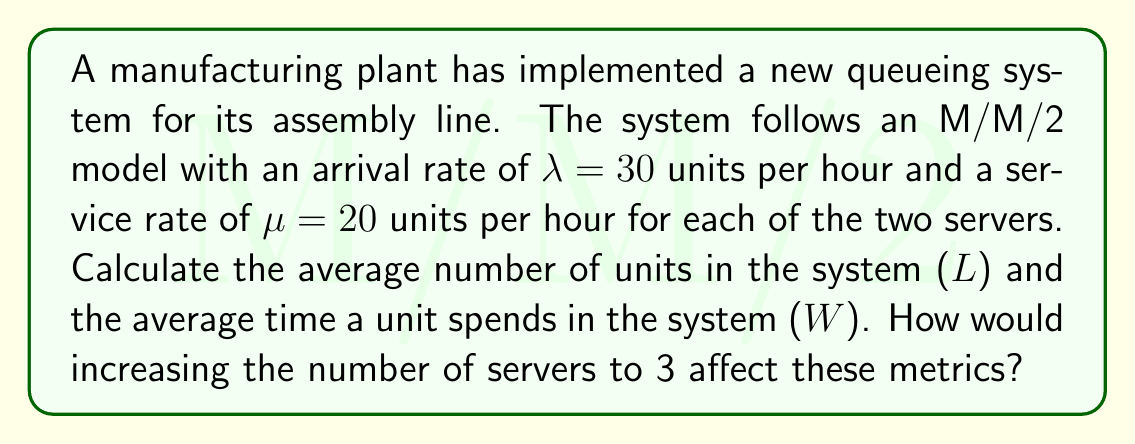Can you answer this question? To solve this problem, we'll use the formulas for an M/M/c queueing system, where c is the number of servers.

Step 1: Calculate the utilization factor ρ
$$\rho = \frac{\lambda}{c\mu} = \frac{30}{2 \cdot 20} = 0.75$$

Step 2: Calculate P0 (probability of an empty system)
$$P_0 = \left[\sum_{n=0}^{c-1}\frac{(c\rho)^n}{n!} + \frac{(c\rho)^c}{c!(1-\rho)}\right]^{-1}$$
$$P_0 = \left[1 + \frac{(2 \cdot 0.75)^1}{1!} + \frac{(2 \cdot 0.75)^2}{2!(1-0.75)}\right]^{-1} = 0.1739$$

Step 3: Calculate Lq (average number of units in the queue)
$$L_q = \frac{P_0(c\rho)^c\rho}{c!(1-\rho)^2} = \frac{0.1739 \cdot (2 \cdot 0.75)^2 \cdot 0.75}{2!(1-0.75)^2} = 2.25$$

Step 4: Calculate L (average number of units in the system)
$$L = L_q + c\rho = 2.25 + 2 \cdot 0.75 = 3.75$$

Step 5: Calculate W (average time a unit spends in the system)
$$W = \frac{L}{\lambda} = \frac{3.75}{30} = 0.125 \text{ hours} = 7.5 \text{ minutes}$$

For the second part of the question, if we increase the number of servers to 3:

Step 1: Recalculate ρ
$$\rho = \frac{\lambda}{c\mu} = \frac{30}{3 \cdot 20} = 0.5$$

Step 2: Recalculate P0
$$P_0 = \left[1 + \frac{(3 \cdot 0.5)^1}{1!} + \frac{(3 \cdot 0.5)^2}{2!} + \frac{(3 \cdot 0.5)^3}{3!(1-0.5)}\right]^{-1} = 0.2727$$

Step 3: Recalculate Lq
$$L_q = \frac{P_0(c\rho)^c\rho}{c!(1-\rho)^2} = \frac{0.2727 \cdot (3 \cdot 0.5)^3 \cdot 0.5}{3!(1-0.5)^2} = 0.2045$$

Step 4: Recalculate L
$$L = L_q + c\rho = 0.2045 + 3 \cdot 0.5 = 1.7045$$

Step 5: Recalculate W
$$W = \frac{L}{\lambda} = \frac{1.7045}{30} = 0.0568 \text{ hours} = 3.41 \text{ minutes}$$

Increasing the number of servers to 3 would reduce both L and W, improving system performance.
Answer: For M/M/2: L = 3.75 units, W = 7.5 minutes. For M/M/3: L = 1.7045 units, W = 3.41 minutes. 